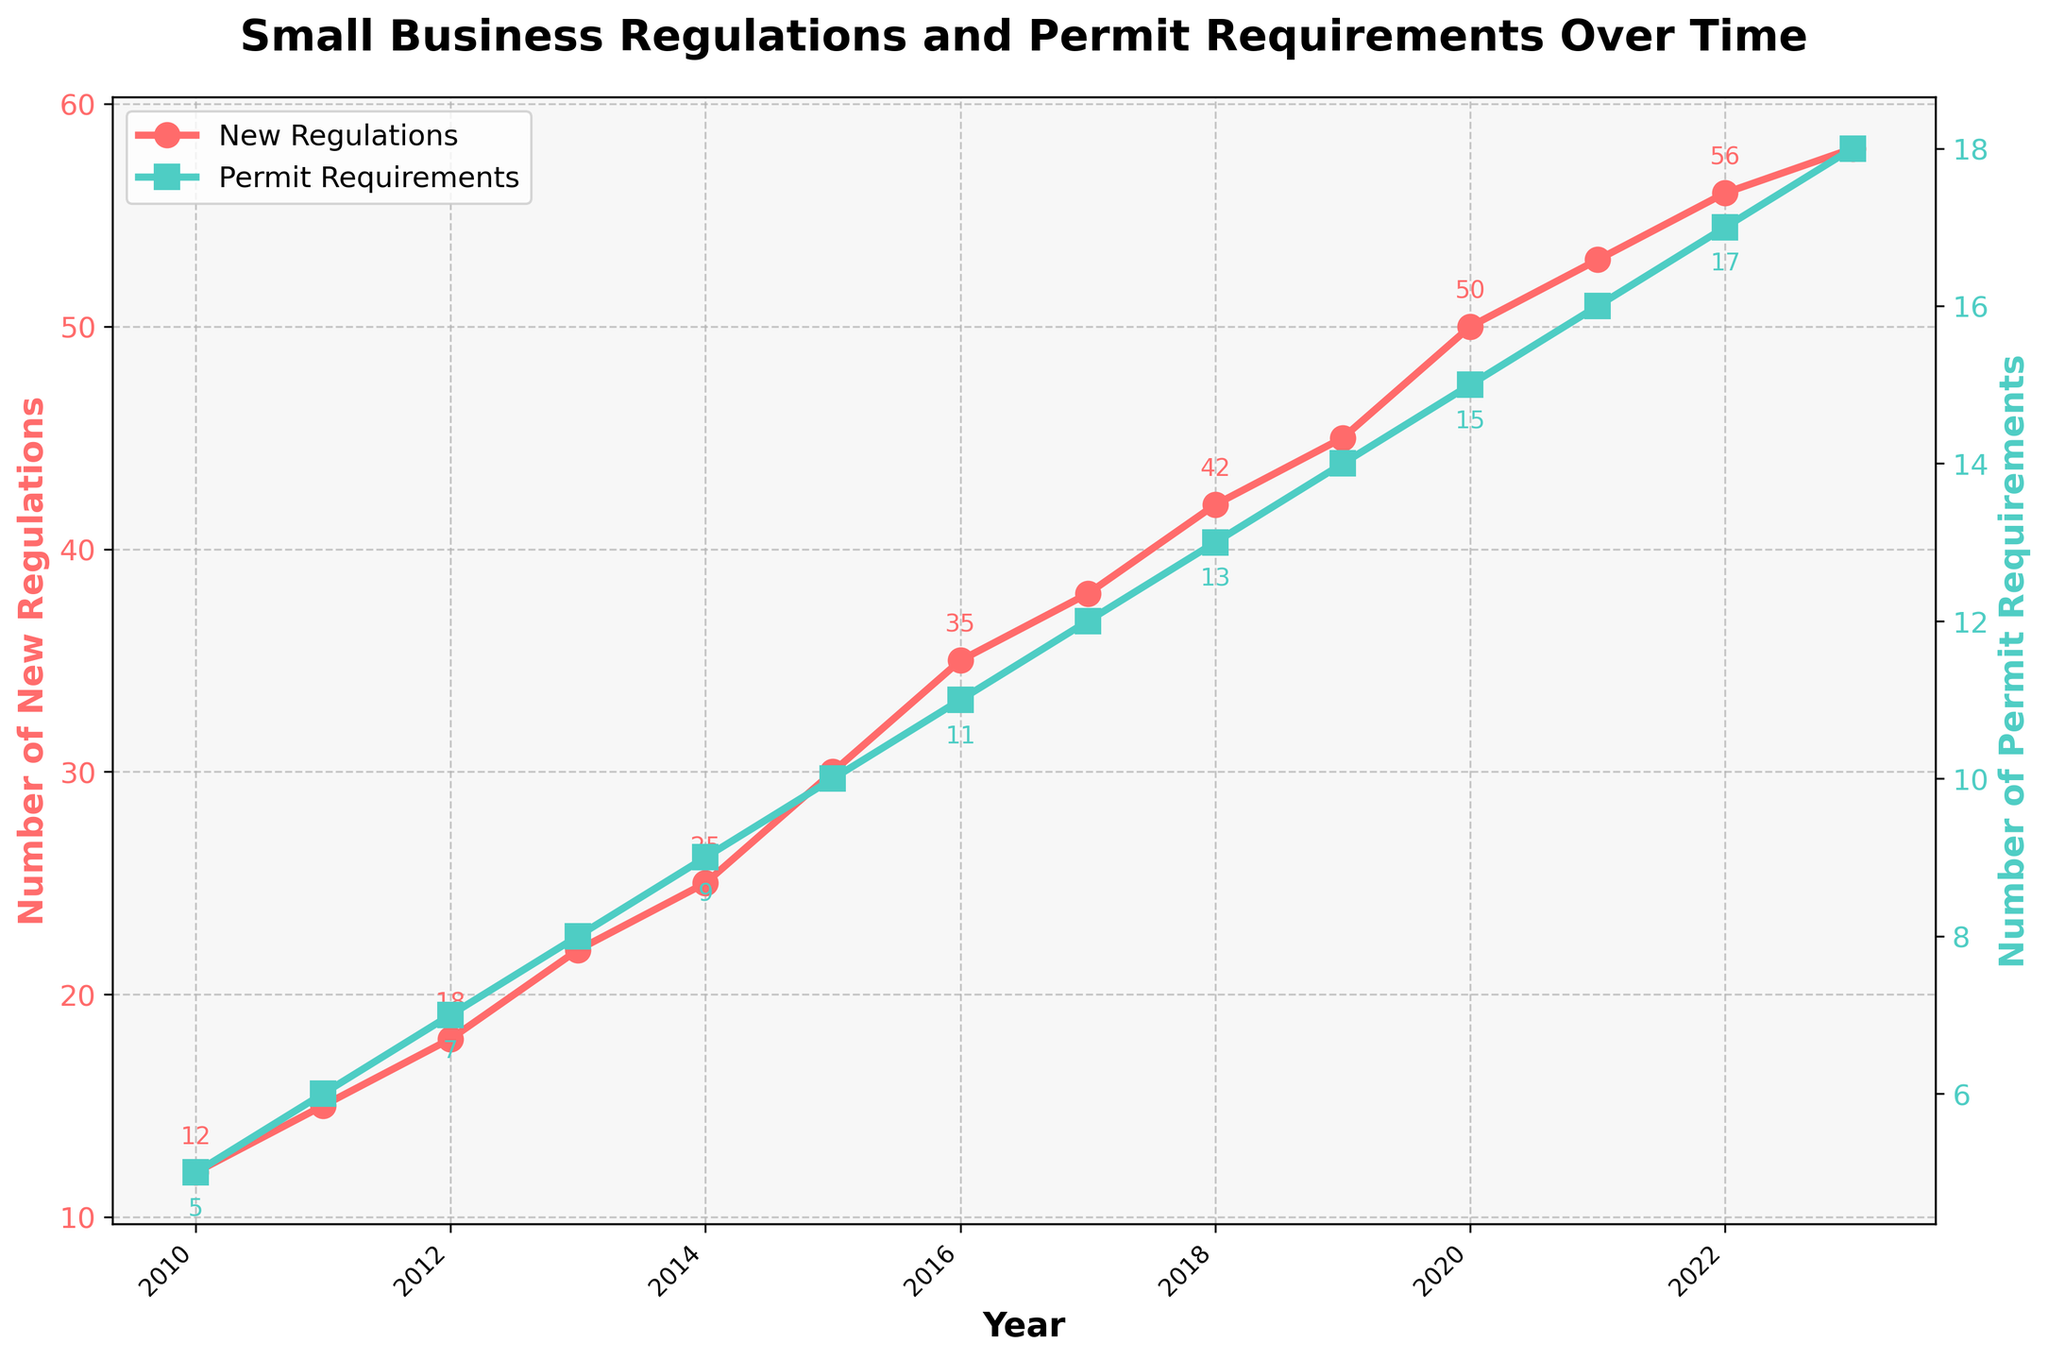How many new small business regulations were introduced in 2015? Locate the year 2015 on the x-axis and look at the value of the red line (New Regulations) for that year.
Answer: 30 How do the permit requirements change from 2010 to 2020? Check the values of the green line (Permit Requirements) at 2010 and 2020, then find the difference: In 2010, the value is 5, and in 2020, it is 15. The change is 15 - 5 = 10.
Answer: Increased by 10 Which year had the highest number of new small business regulations? Find the year with the highest point on the red line (New Regulations). The peak value in 2023 is 58.
Answer: 2023 What is the average number of new small business regulations from 2010 to 2015? Sum up the values from 2010 to 2015: 12 + 15 + 18 + 22 + 25 + 30 = 122, then divide by the number of years: 122 / 6 = 20.33.
Answer: 20.33 In which year did the permit requirements increase by the greatest amount from the previous year? Calculate the annual differences for the green line (Permit Requirements): The greatest increase is from 2014 to 2015 (10 - 9 = 1).
Answer: 2015 Do the new small business regulations and permit requirements increase at the same rate? Compare the slopes of the red and green lines. The red line (New Regulations) has a steeper slope compared to the green line (Permit Requirements), indicating a faster increase in regulations compared to permits.
Answer: No How do the new small business regulations in 2023 compare to those in 2018? Compare the y-values of the red line for 2023 and 2018: 2023 has 58, and 2018 has 42.
Answer: 2023 has 16 more What is the total number of new small business regulations introduced from 2010 to 2023? Sum up all the values for the red line (New Regulations): 12 + 15 + 18 + 22 + 25 + 30 + 35 + 38 + 42 + 45 + 50 + 53 + 56 + 58 = 499.
Answer: 499 Which year saw both new small business regulations and permit requirements increase simultaneously? Identify the years where both red and green lines show a positive slope: 2011, 2012, 2013, 2014, 2015, 2016, 2017, 2018, 2019, 2020, 2021, 2022, 2023.
Answer: 2011-2023 How do permit requirements in 2015 compare to those in 2010? Compare the y-values of the green line for 2015 and 2010: 2015 has 10, and 2010 has 5.
Answer: 2015 has 5 more 